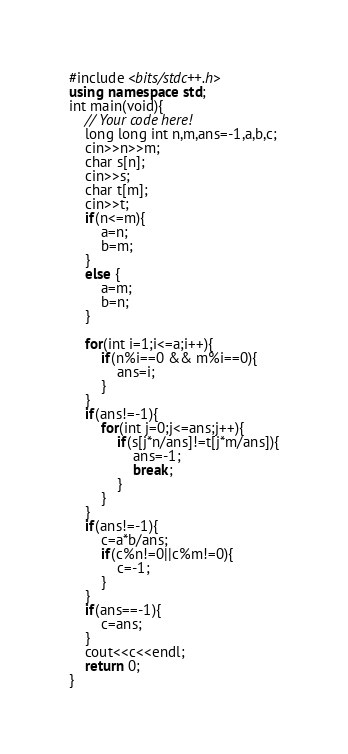<code> <loc_0><loc_0><loc_500><loc_500><_C++_>#include <bits/stdc++.h>
using namespace std;
int main(void){
    // Your code here!
    long long int n,m,ans=-1,a,b,c;
    cin>>n>>m;
    char s[n];
    cin>>s;
    char t[m];
    cin>>t;
    if(n<=m){
        a=n;
        b=m;
    }
    else {
        a=m;
        b=n;
    }    
    
    for(int i=1;i<=a;i++){
        if(n%i==0 && m%i==0){
            ans=i;
        }
    }
    if(ans!=-1){
        for(int j=0;j<=ans;j++){
            if(s[j*n/ans]!=t[j*m/ans]){
                ans=-1;
                break;
            }
        }
    }
    if(ans!=-1){
        c=a*b/ans;
        if(c%n!=0||c%m!=0){
            c=-1;
        }
    }
    if(ans==-1){
        c=ans;
    }    
    cout<<c<<endl;
    return 0;
}
</code> 